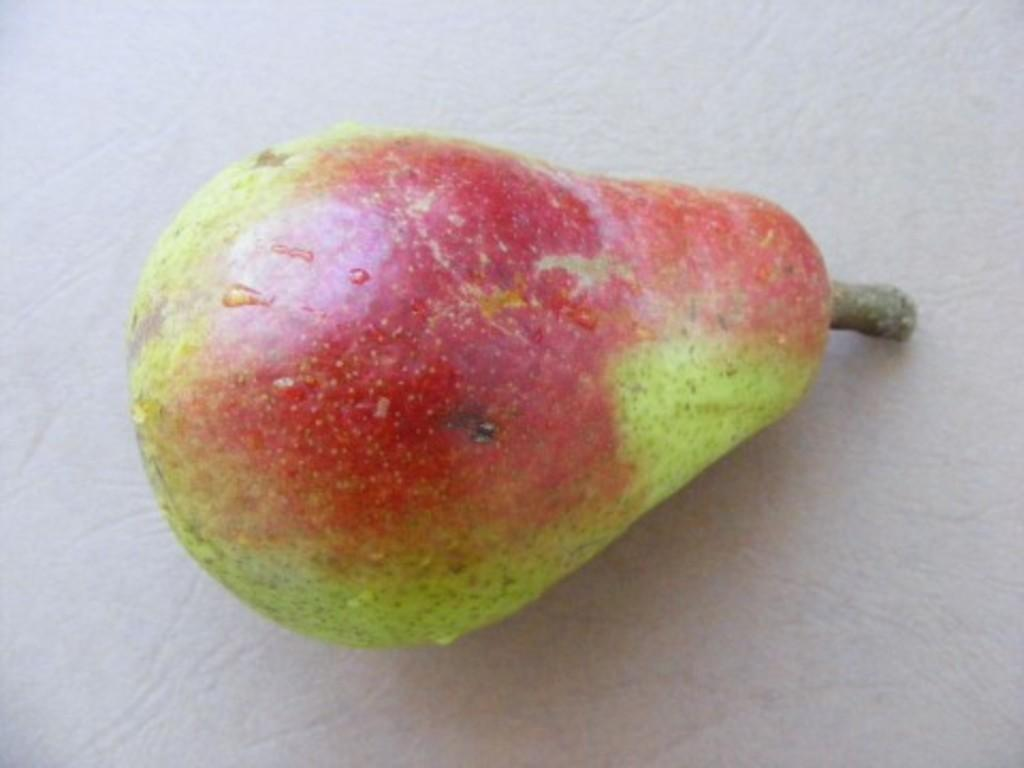What type of fruit is visible in the image? There is a pear in the image. Where is the pear located in the image? The pear is placed on a surface. What type of toothbrush is the pear using in the image? There is no toothbrush present in the image, and pears do not use toothbrushes. 